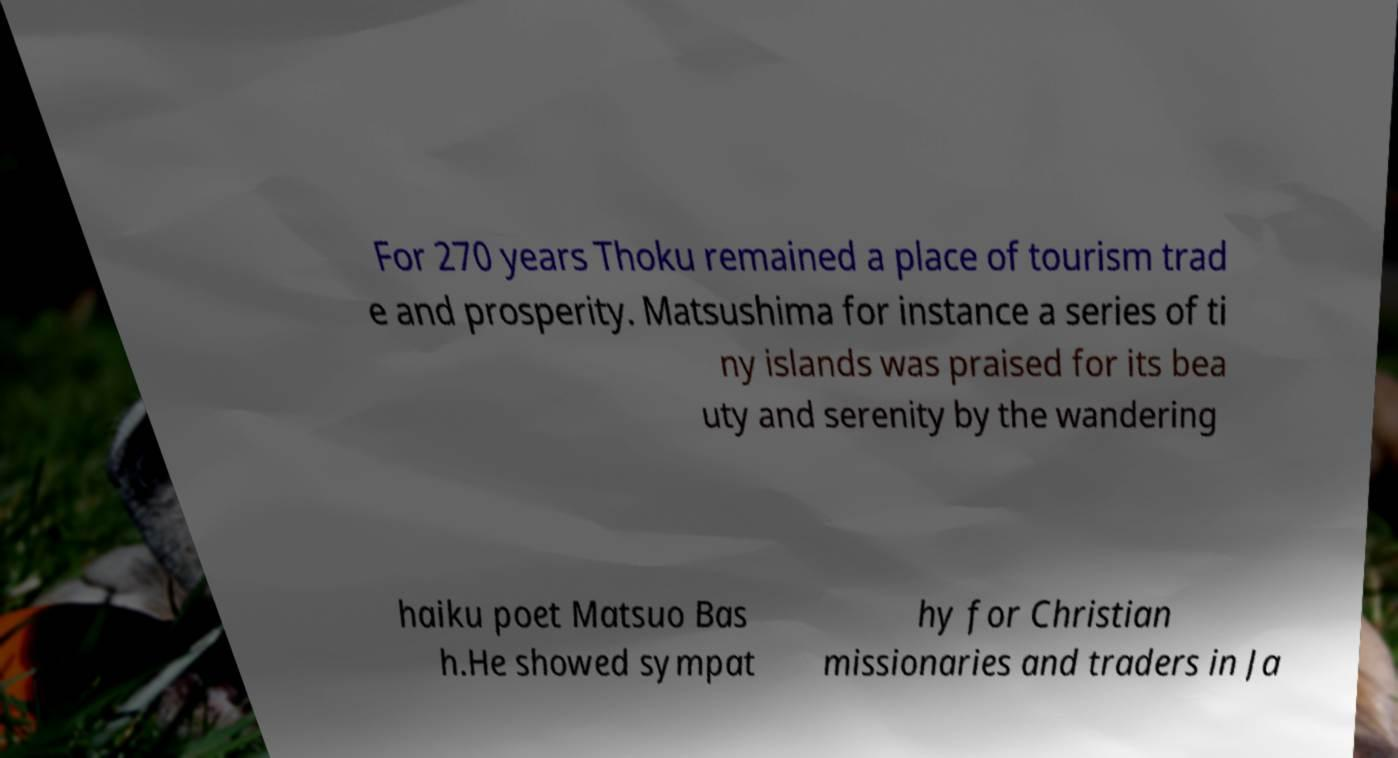Please read and relay the text visible in this image. What does it say? For 270 years Thoku remained a place of tourism trad e and prosperity. Matsushima for instance a series of ti ny islands was praised for its bea uty and serenity by the wandering haiku poet Matsuo Bas h.He showed sympat hy for Christian missionaries and traders in Ja 